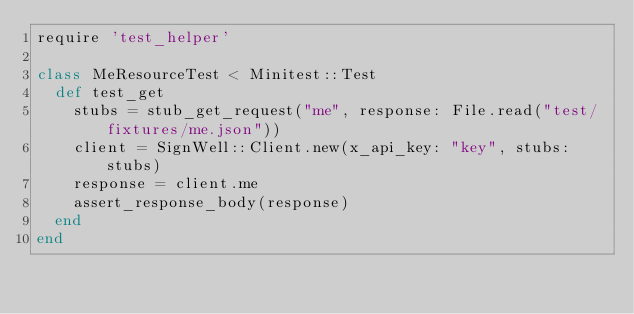<code> <loc_0><loc_0><loc_500><loc_500><_Ruby_>require 'test_helper'

class MeResourceTest < Minitest::Test
  def test_get
    stubs = stub_get_request("me", response: File.read("test/fixtures/me.json"))
    client = SignWell::Client.new(x_api_key: "key", stubs: stubs)
    response = client.me
    assert_response_body(response)
  end
end


</code> 